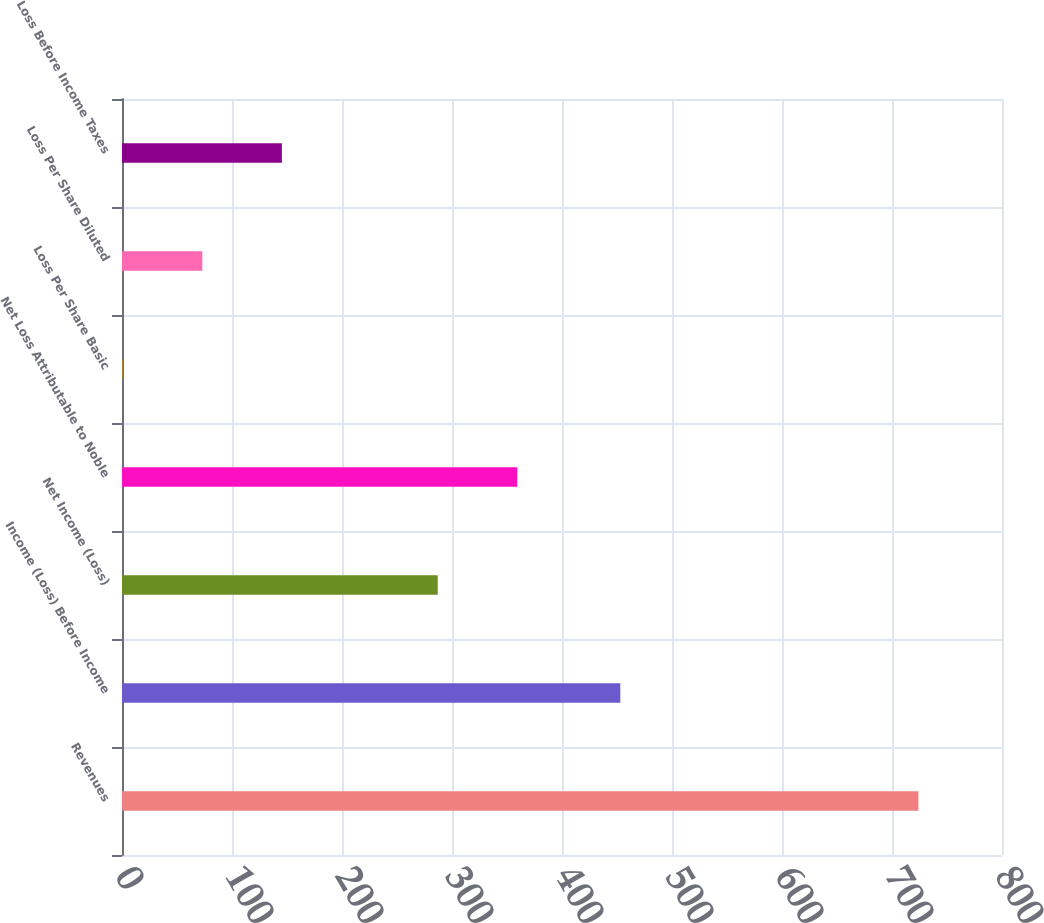<chart> <loc_0><loc_0><loc_500><loc_500><bar_chart><fcel>Revenues<fcel>Income (Loss) Before Income<fcel>Net Income (Loss)<fcel>Net Loss Attributable to Noble<fcel>Loss Per Share Basic<fcel>Loss Per Share Diluted<fcel>Loss Before Income Taxes<nl><fcel>724<fcel>453<fcel>287<fcel>359.33<fcel>0.67<fcel>73<fcel>145.33<nl></chart> 